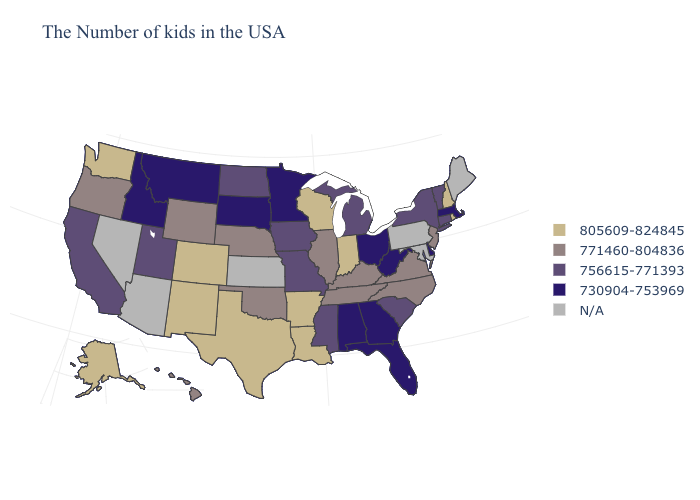What is the highest value in the MidWest ?
Concise answer only. 805609-824845. What is the value of South Carolina?
Quick response, please. 756615-771393. Does New York have the lowest value in the Northeast?
Concise answer only. No. Among the states that border Indiana , which have the highest value?
Write a very short answer. Kentucky, Illinois. What is the lowest value in states that border Mississippi?
Answer briefly. 730904-753969. Does Illinois have the highest value in the USA?
Keep it brief. No. What is the value of Wisconsin?
Concise answer only. 805609-824845. Does Delaware have the highest value in the South?
Answer briefly. No. Which states have the lowest value in the Northeast?
Write a very short answer. Massachusetts. What is the value of Missouri?
Write a very short answer. 756615-771393. Name the states that have a value in the range 756615-771393?
Short answer required. Vermont, Connecticut, New York, South Carolina, Michigan, Mississippi, Missouri, Iowa, North Dakota, Utah, California. Does Vermont have the lowest value in the Northeast?
Be succinct. No. Name the states that have a value in the range N/A?
Short answer required. Maine, Maryland, Pennsylvania, Kansas, Arizona, Nevada. Does Louisiana have the highest value in the USA?
Give a very brief answer. Yes. 